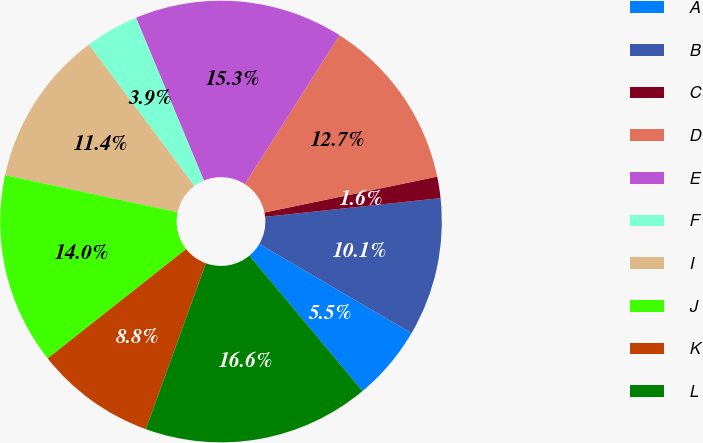<chart> <loc_0><loc_0><loc_500><loc_500><pie_chart><fcel>A<fcel>B<fcel>C<fcel>D<fcel>E<fcel>F<fcel>I<fcel>J<fcel>K<fcel>L<nl><fcel>5.49%<fcel>10.13%<fcel>1.57%<fcel>12.72%<fcel>15.31%<fcel>3.92%<fcel>11.42%<fcel>14.01%<fcel>8.83%<fcel>16.6%<nl></chart> 